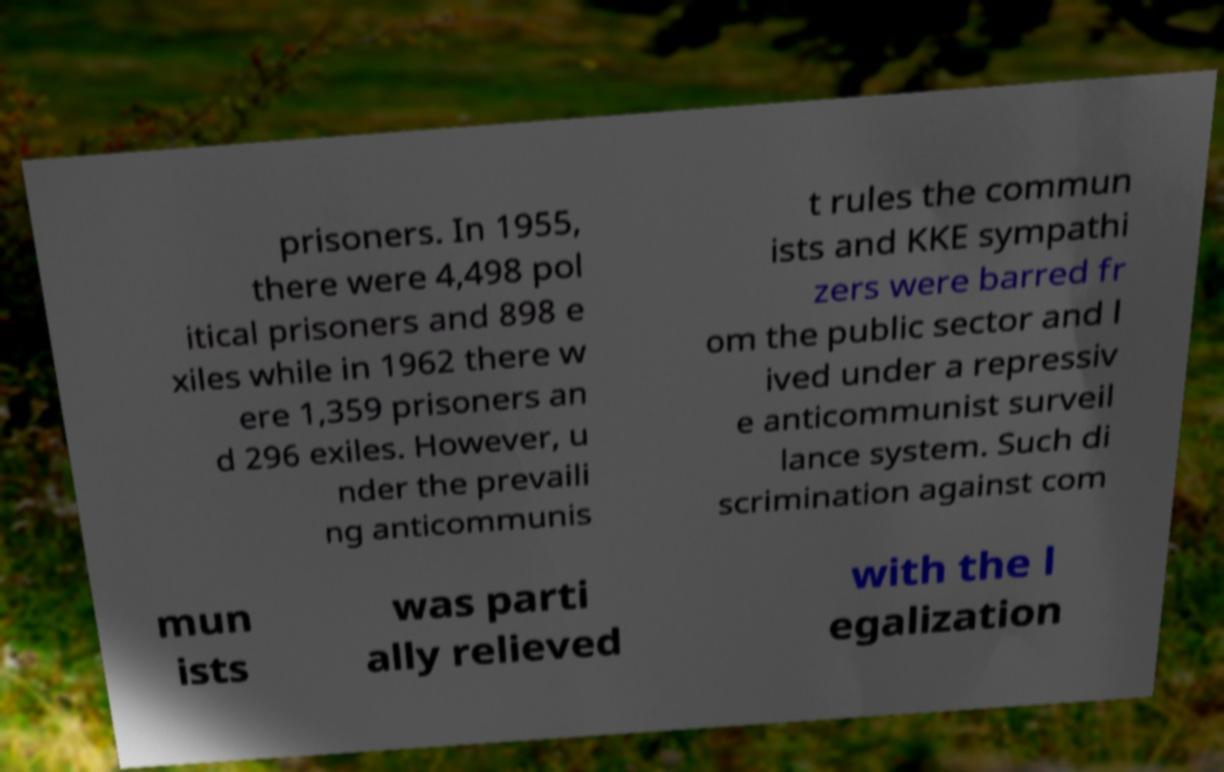What messages or text are displayed in this image? I need them in a readable, typed format. prisoners. In 1955, there were 4,498 pol itical prisoners and 898 e xiles while in 1962 there w ere 1,359 prisoners an d 296 exiles. However, u nder the prevaili ng anticommunis t rules the commun ists and KKE sympathi zers were barred fr om the public sector and l ived under a repressiv e anticommunist surveil lance system. Such di scrimination against com mun ists was parti ally relieved with the l egalization 